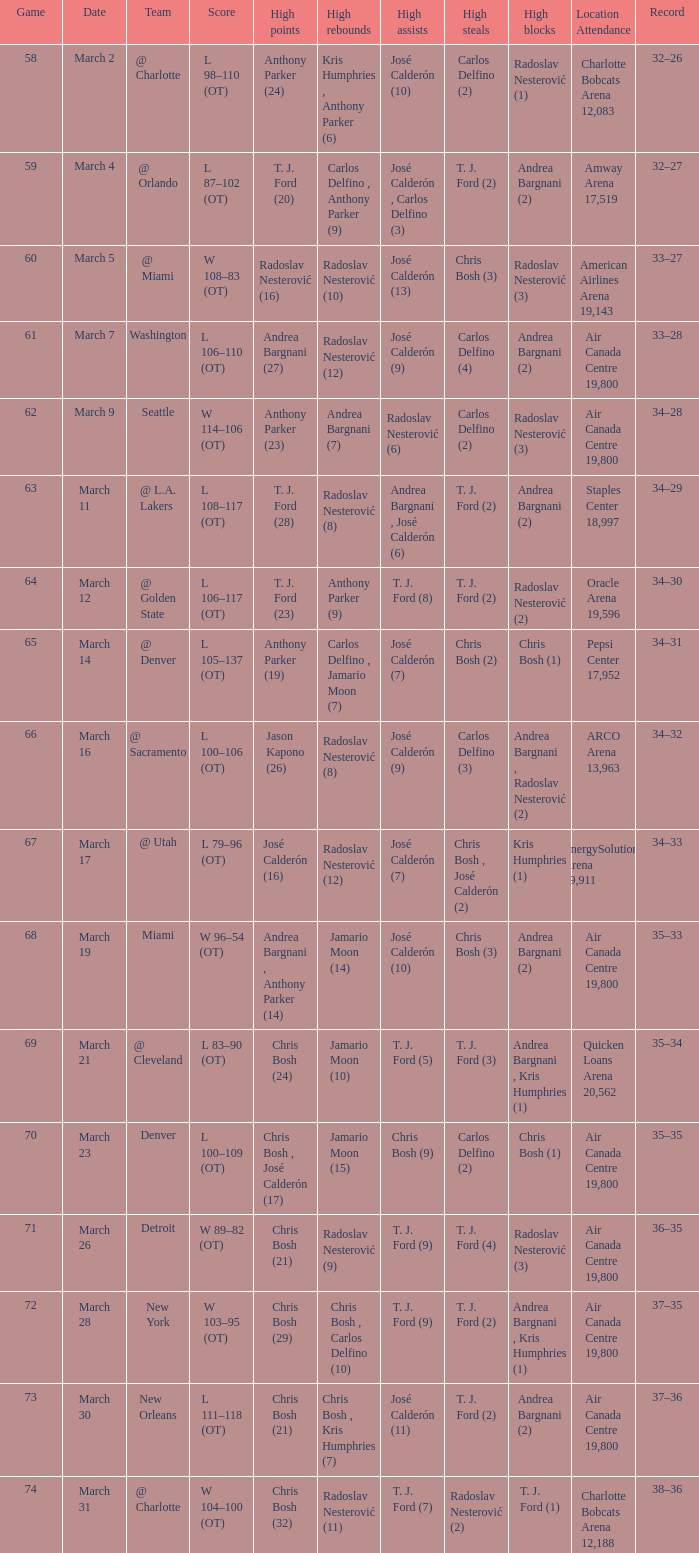What numbered game featured a High rebounds of radoslav nesterović (8), and a High assists of josé calderón (9)? 1.0. 